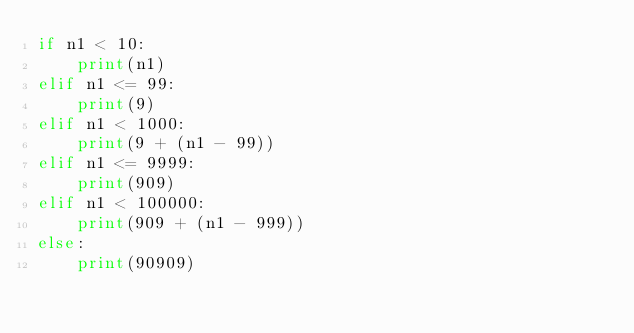<code> <loc_0><loc_0><loc_500><loc_500><_Python_>if n1 < 10:
    print(n1)
elif n1 <= 99:
    print(9)
elif n1 < 1000:
    print(9 + (n1 - 99))
elif n1 <= 9999:
    print(909)
elif n1 < 100000:
    print(909 + (n1 - 999))
else:
    print(90909)</code> 